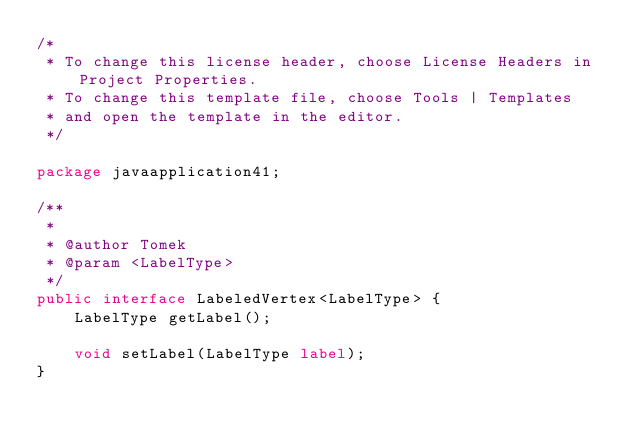<code> <loc_0><loc_0><loc_500><loc_500><_Java_>/*
 * To change this license header, choose License Headers in Project Properties.
 * To change this template file, choose Tools | Templates
 * and open the template in the editor.
 */

package javaapplication41;

/**
 *
 * @author Tomek
 * @param <LabelType>
 */
public interface LabeledVertex<LabelType> {
    LabelType getLabel();

    void setLabel(LabelType label);
}
</code> 